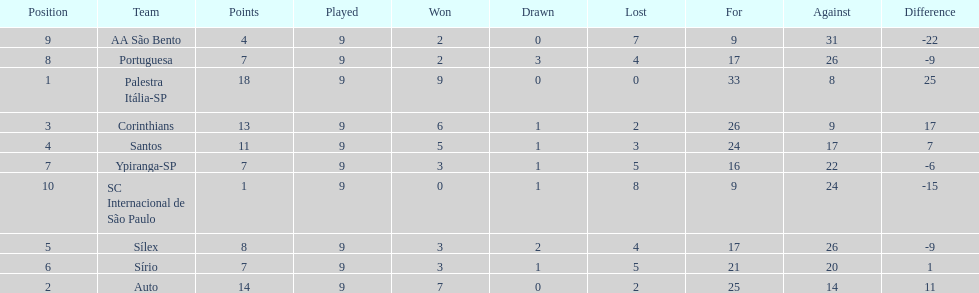Parse the full table. {'header': ['Position', 'Team', 'Points', 'Played', 'Won', 'Drawn', 'Lost', 'For', 'Against', 'Difference'], 'rows': [['9', 'AA São Bento', '4', '9', '2', '0', '7', '9', '31', '-22'], ['8', 'Portuguesa', '7', '9', '2', '3', '4', '17', '26', '-9'], ['1', 'Palestra Itália-SP', '18', '9', '9', '0', '0', '33', '8', '25'], ['3', 'Corinthians', '13', '9', '6', '1', '2', '26', '9', '17'], ['4', 'Santos', '11', '9', '5', '1', '3', '24', '17', '7'], ['7', 'Ypiranga-SP', '7', '9', '3', '1', '5', '16', '22', '-6'], ['10', 'SC Internacional de São Paulo', '1', '9', '0', '1', '8', '9', '24', '-15'], ['5', 'Sílex', '8', '9', '3', '2', '4', '17', '26', '-9'], ['6', 'Sírio', '7', '9', '3', '1', '5', '21', '20', '1'], ['2', 'Auto', '14', '9', '7', '0', '2', '25', '14', '11']]} Which team was the only team that was undefeated? Palestra Itália-SP. 